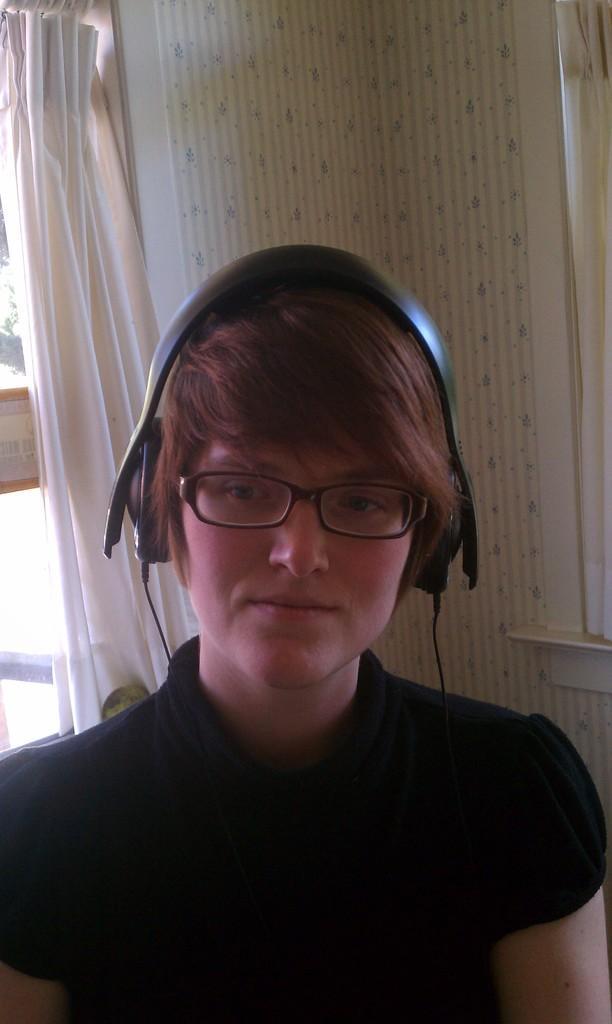How would you summarize this image in a sentence or two? In this image we can see a window and a curtain. There is a lady and she is listening music in the image. 